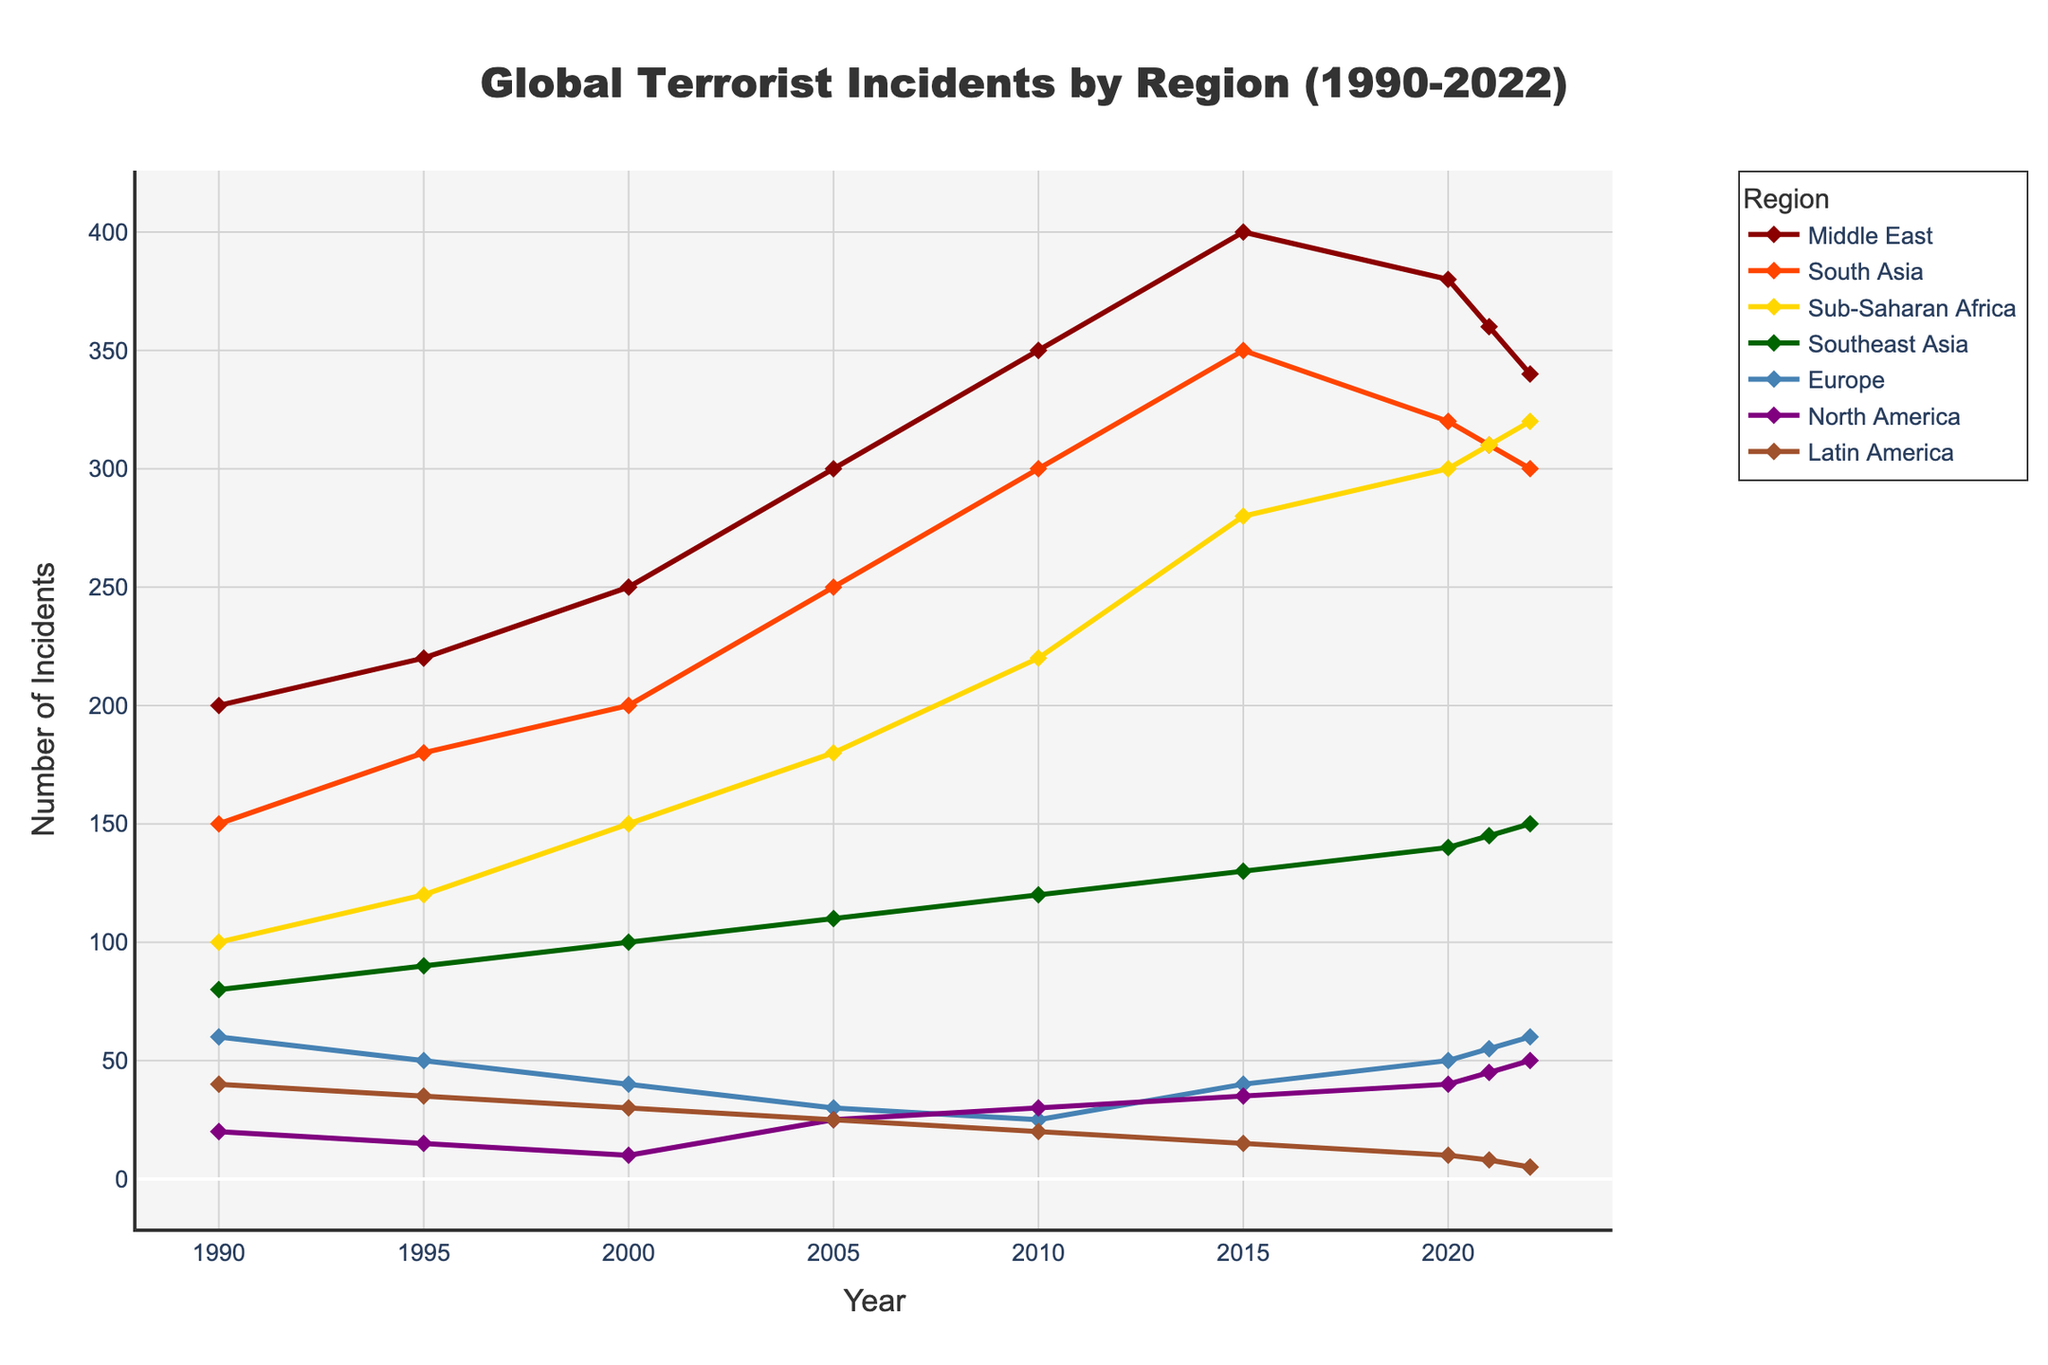What's the overall trend for terrorist incidents in the Middle East region from 1990 to 2022? The trend in the Middle East shows a general increase in terrorist incidents from 1990 to 2015, peaking in 2015 with 400 incidents, followed by a gradual decrease to 340 incidents in 2022.
Answer: Increasing until 2015, then decreasing Which region shows the greatest increase in terrorist incidents from 1990 to 2022? By comparing the data points over the years, Sub-Saharan Africa shows the greatest increase, starting with 100 incidents in 1990 and reaching 320 incidents by 2022. This is an increase of 220 incidents.
Answer: Sub-Saharan Africa In which year did Europe experience its lowest number of terrorist incidents, and what was the value? According to the line graph, Europe's lowest point occurs in 2010 with 25 incidents.
Answer: 2010, 25 incidents What is the difference in the number of terrorist incidents between South Asia and North America in 2022? In 2022, South Asia has 300 incidents, and North America has 50 incidents. The difference is 300 - 50 = 250 incidents.
Answer: 250 incidents Which region consistently had the fewest terrorist incidents from 1990 to 2022? North America had the fewest incidents throughout the entire period, never surpassing 50 incidents annually. The peaks were modest compared to other regions.
Answer: North America What's the average number of terrorist incidents in Latin America between 1990 and 2022? The data points for Latin America are 40, 35, 30, 25, 20, 15, 10, 8, and 5. Sum these values: 40 + 35 + 30 + 25 + 20 + 15 + 10 + 8 + 5 = 188. Divide by 9 (number of data points): 188 / 9 ≈ 20.9 incidents.
Answer: 20.9 incidents Which year had the highest number of terrorist incidents in North America and what was the count? The line graph shows that in 2022, North America experienced its highest number of incidents at 50.
Answer: 2022, 50 incidents How does the trend in Southeast Asia compare visually to that of Europe from 1990 to 2022? Southeast Asia shows a steady increase from 1990 (80 incidents) to 2022 (150 incidents), whereas Europe initially decreases from 60 in 1990 to 25 in 2010, with some fluctuation, but still ends at 60 in 2022.
Answer: Southeast Asia increases steadily, Europe fluctuates and returns to the initial value What is the ratio of terrorist incidents in Sub-Saharan Africa to Middle East in 2022? In 2022, Sub-Saharan Africa has 320 incidents, and the Middle East has 340 incidents. The ratio is 320 / 340 = 0.94.
Answer: 0.94 During which decade did the Middle East see the most significant increase in terrorist incidents? The Middle East experienced the most significant increase between 2000 and 2010, rising from 250 to 350 incidents, an increase of 100 incidents.
Answer: 2000-2010 